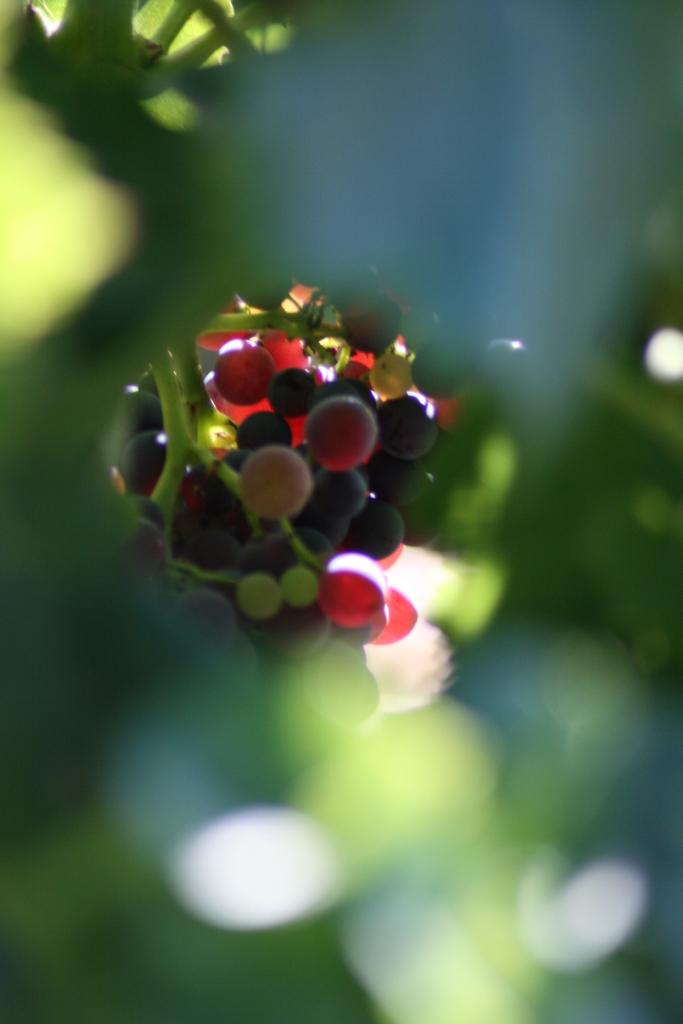What color and objects are in the foreground of the image? There are green color things in the foreground of the image. How are the green color things depicted in the image? The green color things are blurred. What type of fruits can be seen in the background of the image? There are berries in the background of the image. What colors are the berries? The berries are of red and black color. How many cars are parked near the green color things in the image? There are no cars present in the image; it only features green color things and berries. Is there any lead visible in the image? There is no mention of lead in the image, and it is not a visible substance in the context of this image. 